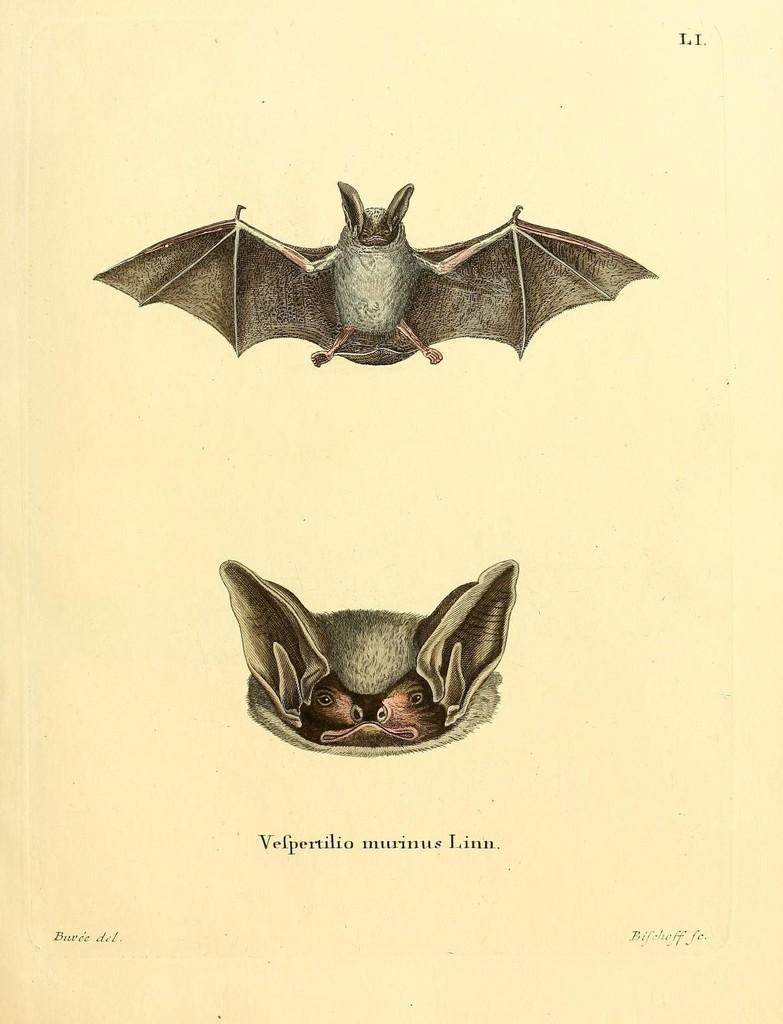Can you describe this image briefly? In this image there is a picture of two bats. 